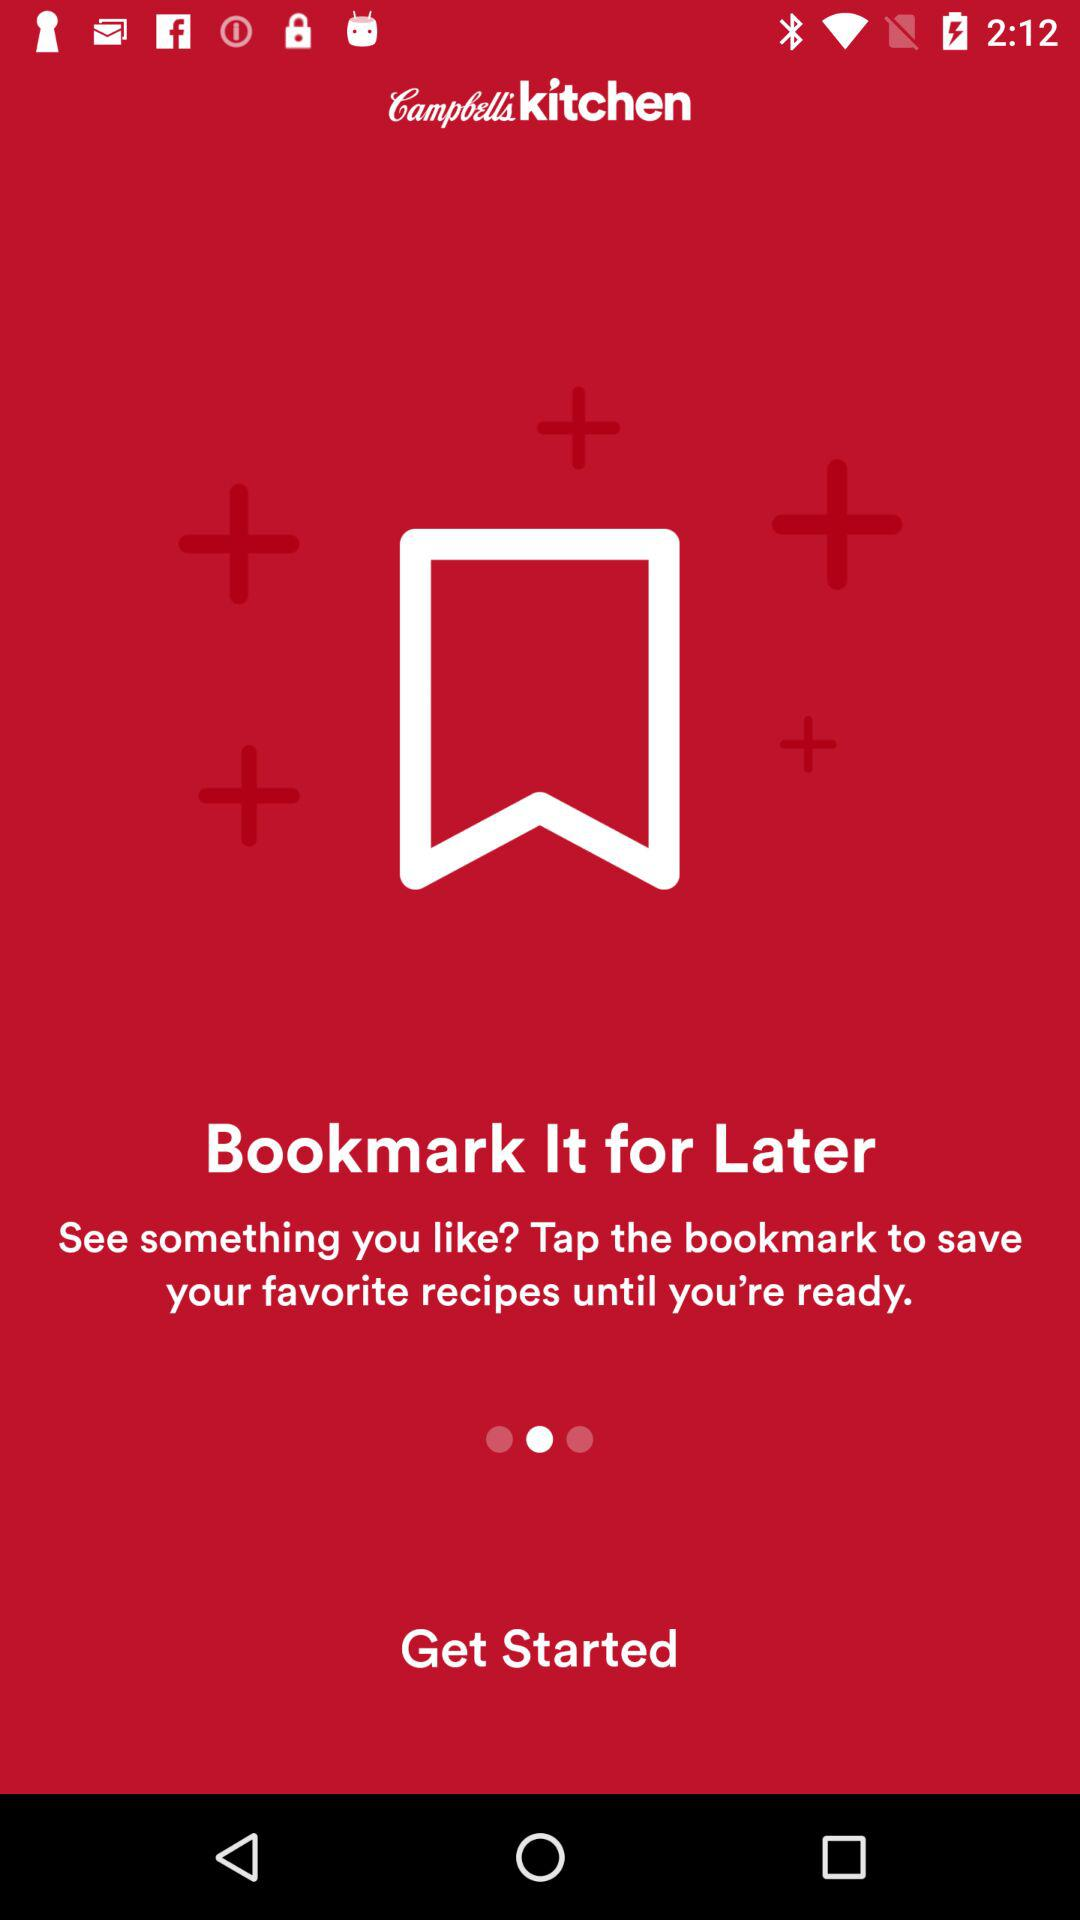What is the application name? The application name is "Campbell's kitchen". 